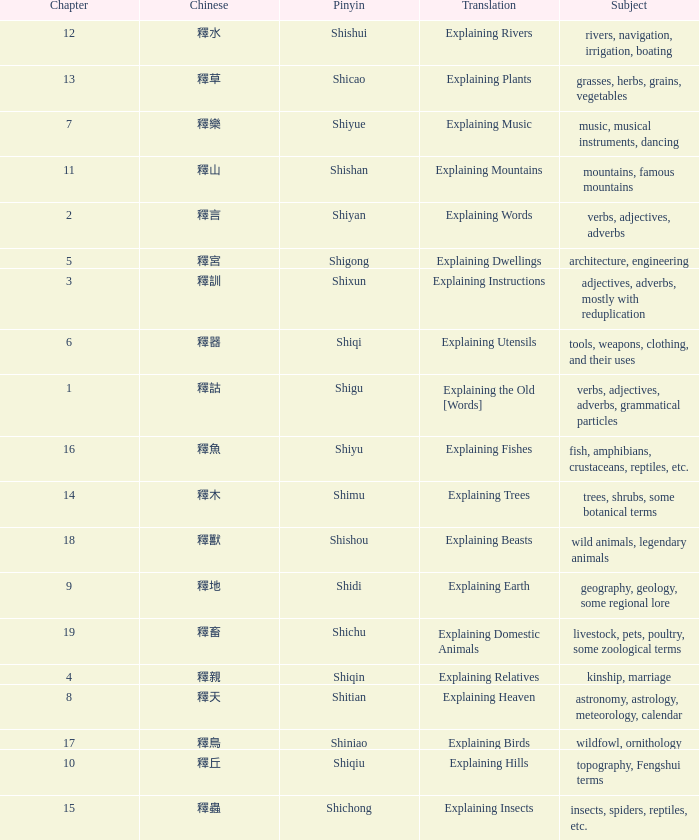Name the chinese with subject of adjectives, adverbs, mostly with reduplication 釋訓. 